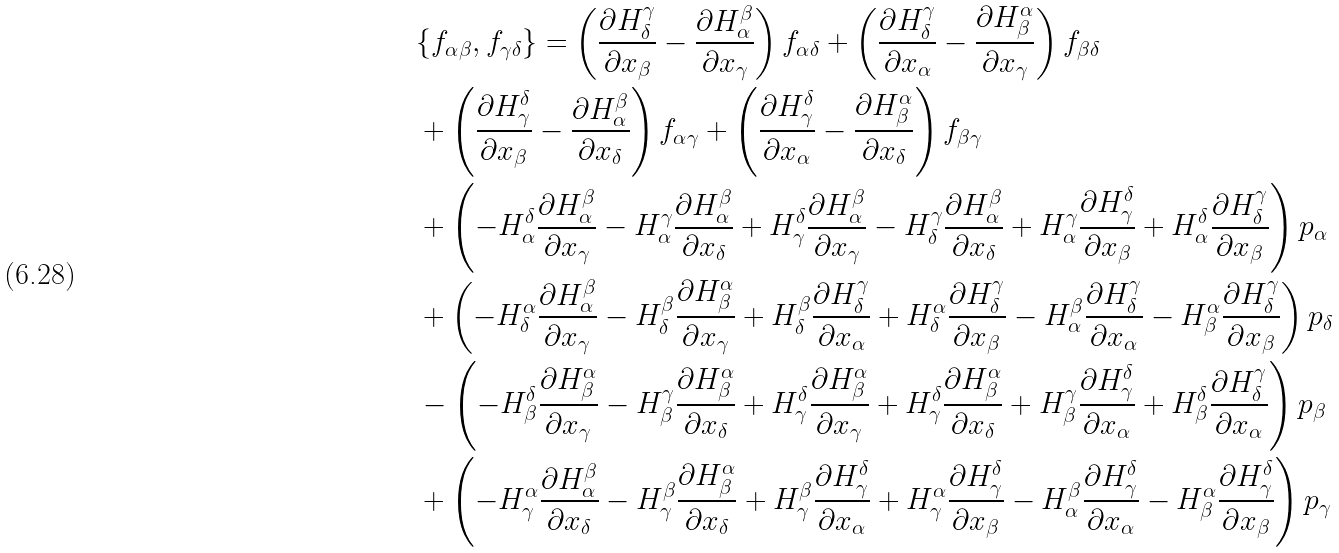Convert formula to latex. <formula><loc_0><loc_0><loc_500><loc_500>& \{ f _ { \alpha \beta } , f _ { \gamma \delta } \} = \left ( \frac { \partial H _ { \delta } ^ { \gamma } } { \partial x _ { \beta } } - \frac { \partial H _ { \alpha } ^ { \beta } } { \partial x _ { \gamma } } \right ) f _ { \alpha \delta } + \left ( \frac { \partial H _ { \delta } ^ { \gamma } } { \partial x _ { \alpha } } - \frac { \partial H _ { \beta } ^ { \alpha } } { \partial x _ { \gamma } } \right ) f _ { \beta \delta } \\ & + \left ( \frac { \partial H _ { \gamma } ^ { \delta } } { \partial x _ { \beta } } - \frac { \partial H _ { \alpha } ^ { \beta } } { \partial x _ { \delta } } \right ) f _ { \alpha \gamma } + \left ( \frac { \partial H _ { \gamma } ^ { \delta } } { \partial x _ { \alpha } } - \frac { \partial H _ { \beta } ^ { \alpha } } { \partial x _ { \delta } } \right ) f _ { \beta \gamma } \\ & + \left ( - H _ { \alpha } ^ { \delta } \frac { \partial H _ { \alpha } ^ { \beta } } { \partial x _ { \gamma } } - H _ { \alpha } ^ { \gamma } \frac { \partial H _ { \alpha } ^ { \beta } } { \partial x _ { \delta } } + H _ { \gamma } ^ { \delta } \frac { \partial H _ { \alpha } ^ { \beta } } { \partial x _ { \gamma } } - H _ { \delta } ^ { \gamma } \frac { \partial H _ { \alpha } ^ { \beta } } { \partial x _ { \delta } } + H _ { \alpha } ^ { \gamma } \frac { \partial H _ { \gamma } ^ { \delta } } { \partial x _ { \beta } } + H _ { \alpha } ^ { \delta } \frac { \partial H _ { \delta } ^ { \gamma } } { \partial x _ { \beta } } \right ) p _ { \alpha } \\ & + \left ( - H _ { \delta } ^ { \alpha } \frac { \partial H _ { \alpha } ^ { \beta } } { \partial x _ { \gamma } } - H _ { \delta } ^ { \beta } \frac { \partial H _ { \beta } ^ { \alpha } } { \partial x _ { \gamma } } + H _ { \delta } ^ { \beta } \frac { \partial H _ { \delta } ^ { \gamma } } { \partial x _ { \alpha } } + H _ { \delta } ^ { \alpha } \frac { \partial H _ { \delta } ^ { \gamma } } { \partial x _ { \beta } } - H _ { \alpha } ^ { \beta } \frac { \partial H _ { \delta } ^ { \gamma } } { \partial x _ { \alpha } } - H _ { \beta } ^ { \alpha } \frac { \partial H _ { \delta } ^ { \gamma } } { \partial x _ { \beta } } \right ) p _ { \delta } \\ & - \left ( - H _ { \beta } ^ { \delta } \frac { \partial H _ { \beta } ^ { \alpha } } { \partial x _ { \gamma } } - H _ { \beta } ^ { \gamma } \frac { \partial H _ { \beta } ^ { \alpha } } { \partial x _ { \delta } } + H _ { \gamma } ^ { \delta } \frac { \partial H _ { \beta } ^ { \alpha } } { \partial x _ { \gamma } } + H _ { \gamma } ^ { \delta } \frac { \partial H _ { \beta } ^ { \alpha } } { \partial x _ { \delta } } + H _ { \beta } ^ { \gamma } \frac { \partial H _ { \gamma } ^ { \delta } } { \partial x _ { \alpha } } + H _ { \beta } ^ { \delta } \frac { \partial H _ { \delta } ^ { \gamma } } { \partial x _ { \alpha } } \right ) p _ { \beta } \\ & + \left ( - H _ { \gamma } ^ { \alpha } \frac { \partial H _ { \alpha } ^ { \beta } } { \partial x _ { \delta } } - H _ { \gamma } ^ { \beta } \frac { \partial H _ { \beta } ^ { \alpha } } { \partial x _ { \delta } } + H _ { \gamma } ^ { \beta } \frac { \partial H _ { \gamma } ^ { \delta } } { \partial x _ { \alpha } } + H _ { \gamma } ^ { \alpha } \frac { \partial H _ { \gamma } ^ { \delta } } { \partial x _ { \beta } } - H _ { \alpha } ^ { \beta } \frac { \partial H _ { \gamma } ^ { \delta } } { \partial x _ { \alpha } } - H _ { \beta } ^ { \alpha } \frac { \partial H _ { \gamma } ^ { \delta } } { \partial x _ { \beta } } \right ) p _ { \gamma } \\</formula> 